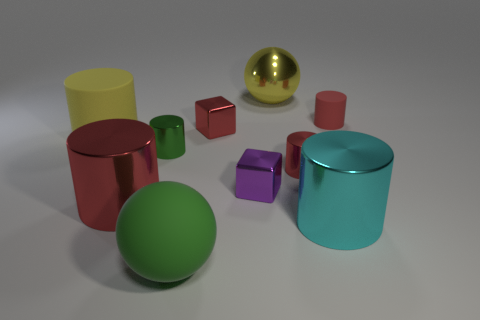Subtract all tiny red rubber cylinders. How many cylinders are left? 5 Subtract all cubes. How many objects are left? 8 Subtract all yellow cylinders. How many cylinders are left? 5 Subtract 1 blocks. How many blocks are left? 1 Add 6 tiny red matte things. How many tiny red matte things are left? 7 Add 5 red matte things. How many red matte things exist? 6 Subtract 2 red cylinders. How many objects are left? 8 Subtract all green balls. Subtract all red cylinders. How many balls are left? 1 Subtract all brown cylinders. How many red cubes are left? 1 Subtract all purple metal blocks. Subtract all purple blocks. How many objects are left? 8 